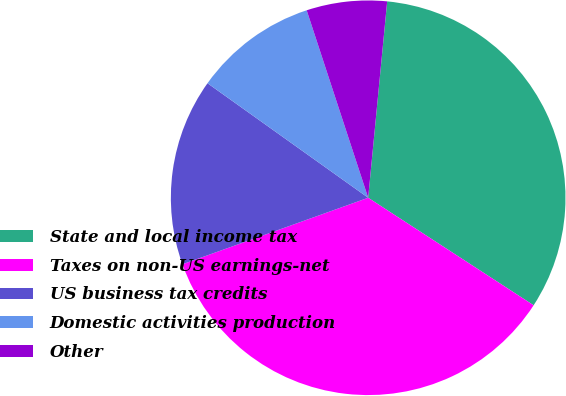<chart> <loc_0><loc_0><loc_500><loc_500><pie_chart><fcel>State and local income tax<fcel>Taxes on non-US earnings-net<fcel>US business tax credits<fcel>Domestic activities production<fcel>Other<nl><fcel>32.64%<fcel>35.36%<fcel>15.33%<fcel>10.1%<fcel>6.58%<nl></chart> 